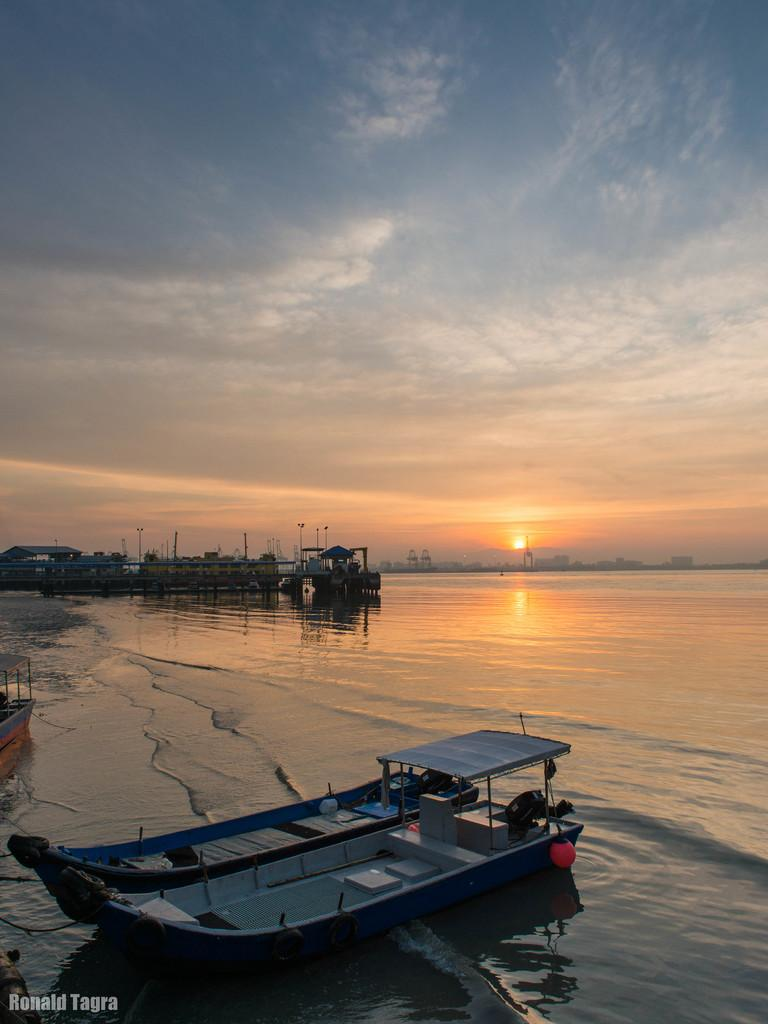What can be seen floating on the water in the image? There are boats in the image. What is the primary element that surrounds the boats? There is water visible in the image. What time of day is depicted in the image? The sunrise is observable in the image. How would you describe the sky in the image? The sky appears to be cloudy. What structures can be seen in the distance? There is a shed and poles in the distance. What type of cap is the juice wearing in the image? There is no cap or juice present in the image. 